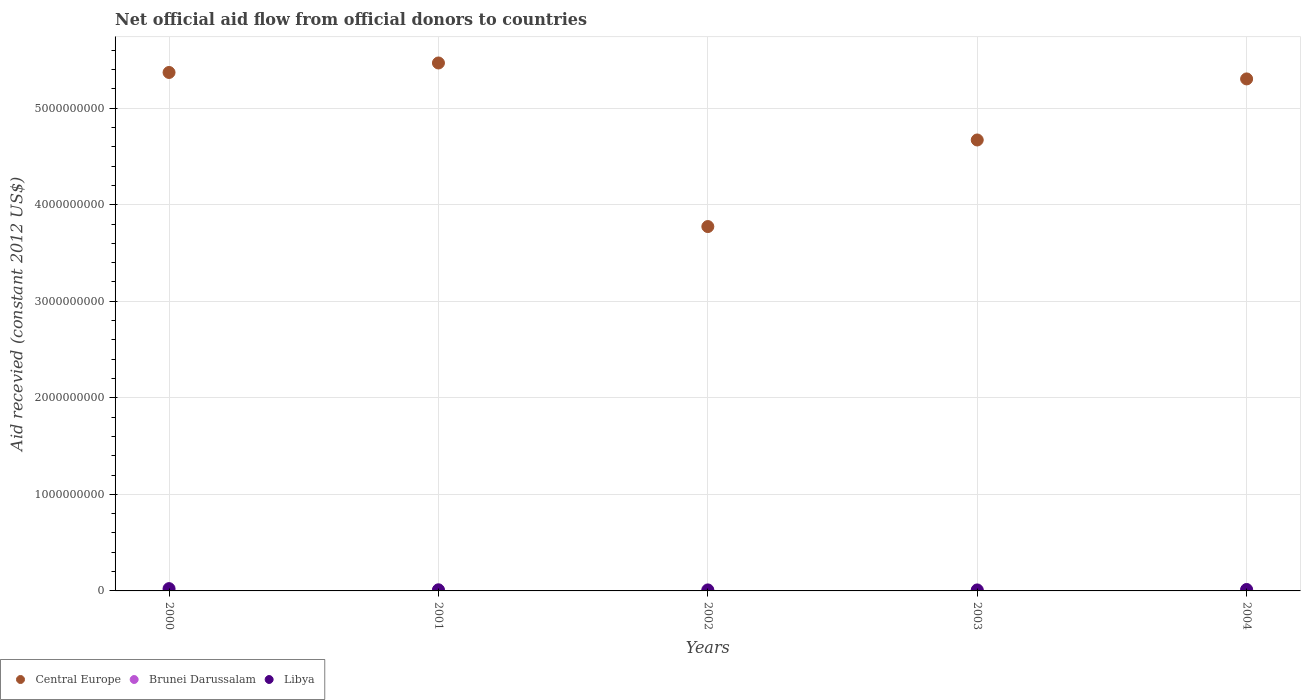Is the number of dotlines equal to the number of legend labels?
Your answer should be very brief. No. What is the total aid received in Brunei Darussalam in 2001?
Provide a succinct answer. 6.00e+05. Across all years, what is the maximum total aid received in Central Europe?
Offer a terse response. 5.47e+09. What is the total total aid received in Libya in the graph?
Your answer should be compact. 7.14e+07. What is the difference between the total aid received in Central Europe in 2003 and that in 2004?
Provide a short and direct response. -6.32e+08. What is the difference between the total aid received in Libya in 2002 and the total aid received in Brunei Darussalam in 2001?
Keep it short and to the point. 9.91e+06. What is the average total aid received in Libya per year?
Your answer should be very brief. 1.43e+07. In the year 2002, what is the difference between the total aid received in Libya and total aid received in Central Europe?
Offer a very short reply. -3.76e+09. In how many years, is the total aid received in Libya greater than 4000000000 US$?
Your answer should be very brief. 0. What is the ratio of the total aid received in Libya in 2000 to that in 2004?
Keep it short and to the point. 1.58. Is the total aid received in Central Europe in 2002 less than that in 2004?
Your answer should be very brief. Yes. What is the difference between the highest and the second highest total aid received in Libya?
Your answer should be very brief. 8.78e+06. What is the difference between the highest and the lowest total aid received in Central Europe?
Offer a terse response. 1.69e+09. In how many years, is the total aid received in Brunei Darussalam greater than the average total aid received in Brunei Darussalam taken over all years?
Offer a very short reply. 2. Is it the case that in every year, the sum of the total aid received in Libya and total aid received in Central Europe  is greater than the total aid received in Brunei Darussalam?
Your answer should be compact. Yes. Does the total aid received in Brunei Darussalam monotonically increase over the years?
Your answer should be compact. No. Is the total aid received in Central Europe strictly greater than the total aid received in Libya over the years?
Ensure brevity in your answer.  Yes. Is the total aid received in Central Europe strictly less than the total aid received in Brunei Darussalam over the years?
Provide a succinct answer. No. How many dotlines are there?
Offer a terse response. 3. Does the graph contain grids?
Your response must be concise. Yes. What is the title of the graph?
Make the answer very short. Net official aid flow from official donors to countries. What is the label or title of the X-axis?
Give a very brief answer. Years. What is the label or title of the Y-axis?
Make the answer very short. Aid recevied (constant 2012 US$). What is the Aid recevied (constant 2012 US$) in Central Europe in 2000?
Your response must be concise. 5.37e+09. What is the Aid recevied (constant 2012 US$) of Brunei Darussalam in 2000?
Make the answer very short. 1.21e+06. What is the Aid recevied (constant 2012 US$) of Libya in 2000?
Your response must be concise. 2.38e+07. What is the Aid recevied (constant 2012 US$) in Central Europe in 2001?
Keep it short and to the point. 5.47e+09. What is the Aid recevied (constant 2012 US$) of Libya in 2001?
Offer a very short reply. 1.17e+07. What is the Aid recevied (constant 2012 US$) in Central Europe in 2002?
Keep it short and to the point. 3.77e+09. What is the Aid recevied (constant 2012 US$) in Libya in 2002?
Ensure brevity in your answer.  1.05e+07. What is the Aid recevied (constant 2012 US$) in Central Europe in 2003?
Offer a very short reply. 4.67e+09. What is the Aid recevied (constant 2012 US$) in Libya in 2003?
Provide a succinct answer. 1.03e+07. What is the Aid recevied (constant 2012 US$) of Central Europe in 2004?
Your answer should be very brief. 5.30e+09. What is the Aid recevied (constant 2012 US$) of Brunei Darussalam in 2004?
Provide a succinct answer. 9.40e+05. What is the Aid recevied (constant 2012 US$) in Libya in 2004?
Offer a very short reply. 1.50e+07. Across all years, what is the maximum Aid recevied (constant 2012 US$) of Central Europe?
Provide a short and direct response. 5.47e+09. Across all years, what is the maximum Aid recevied (constant 2012 US$) of Brunei Darussalam?
Your answer should be very brief. 1.21e+06. Across all years, what is the maximum Aid recevied (constant 2012 US$) of Libya?
Your answer should be compact. 2.38e+07. Across all years, what is the minimum Aid recevied (constant 2012 US$) of Central Europe?
Provide a short and direct response. 3.77e+09. Across all years, what is the minimum Aid recevied (constant 2012 US$) in Brunei Darussalam?
Ensure brevity in your answer.  0. Across all years, what is the minimum Aid recevied (constant 2012 US$) in Libya?
Provide a short and direct response. 1.03e+07. What is the total Aid recevied (constant 2012 US$) of Central Europe in the graph?
Your answer should be very brief. 2.46e+1. What is the total Aid recevied (constant 2012 US$) of Brunei Darussalam in the graph?
Your answer should be very brief. 3.35e+06. What is the total Aid recevied (constant 2012 US$) in Libya in the graph?
Give a very brief answer. 7.14e+07. What is the difference between the Aid recevied (constant 2012 US$) in Central Europe in 2000 and that in 2001?
Your response must be concise. -9.83e+07. What is the difference between the Aid recevied (constant 2012 US$) in Libya in 2000 and that in 2001?
Keep it short and to the point. 1.21e+07. What is the difference between the Aid recevied (constant 2012 US$) of Central Europe in 2000 and that in 2002?
Your answer should be very brief. 1.60e+09. What is the difference between the Aid recevied (constant 2012 US$) in Libya in 2000 and that in 2002?
Your answer should be very brief. 1.33e+07. What is the difference between the Aid recevied (constant 2012 US$) in Central Europe in 2000 and that in 2003?
Provide a short and direct response. 6.99e+08. What is the difference between the Aid recevied (constant 2012 US$) of Brunei Darussalam in 2000 and that in 2003?
Your response must be concise. 6.10e+05. What is the difference between the Aid recevied (constant 2012 US$) of Libya in 2000 and that in 2003?
Provide a succinct answer. 1.34e+07. What is the difference between the Aid recevied (constant 2012 US$) of Central Europe in 2000 and that in 2004?
Your answer should be very brief. 6.68e+07. What is the difference between the Aid recevied (constant 2012 US$) of Brunei Darussalam in 2000 and that in 2004?
Your answer should be compact. 2.70e+05. What is the difference between the Aid recevied (constant 2012 US$) of Libya in 2000 and that in 2004?
Your answer should be very brief. 8.78e+06. What is the difference between the Aid recevied (constant 2012 US$) in Central Europe in 2001 and that in 2002?
Offer a terse response. 1.69e+09. What is the difference between the Aid recevied (constant 2012 US$) in Libya in 2001 and that in 2002?
Your response must be concise. 1.22e+06. What is the difference between the Aid recevied (constant 2012 US$) of Central Europe in 2001 and that in 2003?
Ensure brevity in your answer.  7.98e+08. What is the difference between the Aid recevied (constant 2012 US$) of Brunei Darussalam in 2001 and that in 2003?
Provide a short and direct response. 0. What is the difference between the Aid recevied (constant 2012 US$) in Libya in 2001 and that in 2003?
Make the answer very short. 1.39e+06. What is the difference between the Aid recevied (constant 2012 US$) of Central Europe in 2001 and that in 2004?
Your answer should be compact. 1.65e+08. What is the difference between the Aid recevied (constant 2012 US$) of Libya in 2001 and that in 2004?
Your answer should be compact. -3.28e+06. What is the difference between the Aid recevied (constant 2012 US$) of Central Europe in 2002 and that in 2003?
Provide a succinct answer. -8.97e+08. What is the difference between the Aid recevied (constant 2012 US$) in Libya in 2002 and that in 2003?
Keep it short and to the point. 1.70e+05. What is the difference between the Aid recevied (constant 2012 US$) of Central Europe in 2002 and that in 2004?
Provide a short and direct response. -1.53e+09. What is the difference between the Aid recevied (constant 2012 US$) in Libya in 2002 and that in 2004?
Provide a short and direct response. -4.50e+06. What is the difference between the Aid recevied (constant 2012 US$) in Central Europe in 2003 and that in 2004?
Your answer should be compact. -6.32e+08. What is the difference between the Aid recevied (constant 2012 US$) in Libya in 2003 and that in 2004?
Offer a very short reply. -4.67e+06. What is the difference between the Aid recevied (constant 2012 US$) in Central Europe in 2000 and the Aid recevied (constant 2012 US$) in Brunei Darussalam in 2001?
Your answer should be very brief. 5.37e+09. What is the difference between the Aid recevied (constant 2012 US$) of Central Europe in 2000 and the Aid recevied (constant 2012 US$) of Libya in 2001?
Your answer should be compact. 5.36e+09. What is the difference between the Aid recevied (constant 2012 US$) in Brunei Darussalam in 2000 and the Aid recevied (constant 2012 US$) in Libya in 2001?
Make the answer very short. -1.05e+07. What is the difference between the Aid recevied (constant 2012 US$) in Central Europe in 2000 and the Aid recevied (constant 2012 US$) in Libya in 2002?
Your answer should be very brief. 5.36e+09. What is the difference between the Aid recevied (constant 2012 US$) in Brunei Darussalam in 2000 and the Aid recevied (constant 2012 US$) in Libya in 2002?
Your answer should be very brief. -9.30e+06. What is the difference between the Aid recevied (constant 2012 US$) of Central Europe in 2000 and the Aid recevied (constant 2012 US$) of Brunei Darussalam in 2003?
Give a very brief answer. 5.37e+09. What is the difference between the Aid recevied (constant 2012 US$) of Central Europe in 2000 and the Aid recevied (constant 2012 US$) of Libya in 2003?
Give a very brief answer. 5.36e+09. What is the difference between the Aid recevied (constant 2012 US$) in Brunei Darussalam in 2000 and the Aid recevied (constant 2012 US$) in Libya in 2003?
Offer a terse response. -9.13e+06. What is the difference between the Aid recevied (constant 2012 US$) in Central Europe in 2000 and the Aid recevied (constant 2012 US$) in Brunei Darussalam in 2004?
Ensure brevity in your answer.  5.37e+09. What is the difference between the Aid recevied (constant 2012 US$) in Central Europe in 2000 and the Aid recevied (constant 2012 US$) in Libya in 2004?
Ensure brevity in your answer.  5.36e+09. What is the difference between the Aid recevied (constant 2012 US$) of Brunei Darussalam in 2000 and the Aid recevied (constant 2012 US$) of Libya in 2004?
Offer a very short reply. -1.38e+07. What is the difference between the Aid recevied (constant 2012 US$) of Central Europe in 2001 and the Aid recevied (constant 2012 US$) of Libya in 2002?
Provide a succinct answer. 5.46e+09. What is the difference between the Aid recevied (constant 2012 US$) of Brunei Darussalam in 2001 and the Aid recevied (constant 2012 US$) of Libya in 2002?
Keep it short and to the point. -9.91e+06. What is the difference between the Aid recevied (constant 2012 US$) in Central Europe in 2001 and the Aid recevied (constant 2012 US$) in Brunei Darussalam in 2003?
Your answer should be very brief. 5.47e+09. What is the difference between the Aid recevied (constant 2012 US$) in Central Europe in 2001 and the Aid recevied (constant 2012 US$) in Libya in 2003?
Give a very brief answer. 5.46e+09. What is the difference between the Aid recevied (constant 2012 US$) in Brunei Darussalam in 2001 and the Aid recevied (constant 2012 US$) in Libya in 2003?
Make the answer very short. -9.74e+06. What is the difference between the Aid recevied (constant 2012 US$) of Central Europe in 2001 and the Aid recevied (constant 2012 US$) of Brunei Darussalam in 2004?
Provide a succinct answer. 5.47e+09. What is the difference between the Aid recevied (constant 2012 US$) in Central Europe in 2001 and the Aid recevied (constant 2012 US$) in Libya in 2004?
Your answer should be very brief. 5.45e+09. What is the difference between the Aid recevied (constant 2012 US$) of Brunei Darussalam in 2001 and the Aid recevied (constant 2012 US$) of Libya in 2004?
Your response must be concise. -1.44e+07. What is the difference between the Aid recevied (constant 2012 US$) of Central Europe in 2002 and the Aid recevied (constant 2012 US$) of Brunei Darussalam in 2003?
Your answer should be compact. 3.77e+09. What is the difference between the Aid recevied (constant 2012 US$) of Central Europe in 2002 and the Aid recevied (constant 2012 US$) of Libya in 2003?
Offer a terse response. 3.76e+09. What is the difference between the Aid recevied (constant 2012 US$) in Central Europe in 2002 and the Aid recevied (constant 2012 US$) in Brunei Darussalam in 2004?
Make the answer very short. 3.77e+09. What is the difference between the Aid recevied (constant 2012 US$) of Central Europe in 2002 and the Aid recevied (constant 2012 US$) of Libya in 2004?
Your answer should be very brief. 3.76e+09. What is the difference between the Aid recevied (constant 2012 US$) in Central Europe in 2003 and the Aid recevied (constant 2012 US$) in Brunei Darussalam in 2004?
Offer a terse response. 4.67e+09. What is the difference between the Aid recevied (constant 2012 US$) in Central Europe in 2003 and the Aid recevied (constant 2012 US$) in Libya in 2004?
Provide a short and direct response. 4.66e+09. What is the difference between the Aid recevied (constant 2012 US$) in Brunei Darussalam in 2003 and the Aid recevied (constant 2012 US$) in Libya in 2004?
Your answer should be compact. -1.44e+07. What is the average Aid recevied (constant 2012 US$) in Central Europe per year?
Your answer should be compact. 4.92e+09. What is the average Aid recevied (constant 2012 US$) of Brunei Darussalam per year?
Offer a very short reply. 6.70e+05. What is the average Aid recevied (constant 2012 US$) in Libya per year?
Give a very brief answer. 1.43e+07. In the year 2000, what is the difference between the Aid recevied (constant 2012 US$) in Central Europe and Aid recevied (constant 2012 US$) in Brunei Darussalam?
Provide a short and direct response. 5.37e+09. In the year 2000, what is the difference between the Aid recevied (constant 2012 US$) in Central Europe and Aid recevied (constant 2012 US$) in Libya?
Your answer should be compact. 5.35e+09. In the year 2000, what is the difference between the Aid recevied (constant 2012 US$) in Brunei Darussalam and Aid recevied (constant 2012 US$) in Libya?
Offer a terse response. -2.26e+07. In the year 2001, what is the difference between the Aid recevied (constant 2012 US$) of Central Europe and Aid recevied (constant 2012 US$) of Brunei Darussalam?
Offer a terse response. 5.47e+09. In the year 2001, what is the difference between the Aid recevied (constant 2012 US$) in Central Europe and Aid recevied (constant 2012 US$) in Libya?
Keep it short and to the point. 5.46e+09. In the year 2001, what is the difference between the Aid recevied (constant 2012 US$) of Brunei Darussalam and Aid recevied (constant 2012 US$) of Libya?
Your response must be concise. -1.11e+07. In the year 2002, what is the difference between the Aid recevied (constant 2012 US$) in Central Europe and Aid recevied (constant 2012 US$) in Libya?
Offer a very short reply. 3.76e+09. In the year 2003, what is the difference between the Aid recevied (constant 2012 US$) in Central Europe and Aid recevied (constant 2012 US$) in Brunei Darussalam?
Offer a very short reply. 4.67e+09. In the year 2003, what is the difference between the Aid recevied (constant 2012 US$) in Central Europe and Aid recevied (constant 2012 US$) in Libya?
Provide a short and direct response. 4.66e+09. In the year 2003, what is the difference between the Aid recevied (constant 2012 US$) of Brunei Darussalam and Aid recevied (constant 2012 US$) of Libya?
Give a very brief answer. -9.74e+06. In the year 2004, what is the difference between the Aid recevied (constant 2012 US$) of Central Europe and Aid recevied (constant 2012 US$) of Brunei Darussalam?
Your response must be concise. 5.30e+09. In the year 2004, what is the difference between the Aid recevied (constant 2012 US$) in Central Europe and Aid recevied (constant 2012 US$) in Libya?
Ensure brevity in your answer.  5.29e+09. In the year 2004, what is the difference between the Aid recevied (constant 2012 US$) in Brunei Darussalam and Aid recevied (constant 2012 US$) in Libya?
Ensure brevity in your answer.  -1.41e+07. What is the ratio of the Aid recevied (constant 2012 US$) of Central Europe in 2000 to that in 2001?
Offer a very short reply. 0.98. What is the ratio of the Aid recevied (constant 2012 US$) of Brunei Darussalam in 2000 to that in 2001?
Your answer should be compact. 2.02. What is the ratio of the Aid recevied (constant 2012 US$) of Libya in 2000 to that in 2001?
Offer a very short reply. 2.03. What is the ratio of the Aid recevied (constant 2012 US$) of Central Europe in 2000 to that in 2002?
Offer a very short reply. 1.42. What is the ratio of the Aid recevied (constant 2012 US$) of Libya in 2000 to that in 2002?
Offer a terse response. 2.26. What is the ratio of the Aid recevied (constant 2012 US$) in Central Europe in 2000 to that in 2003?
Your answer should be compact. 1.15. What is the ratio of the Aid recevied (constant 2012 US$) in Brunei Darussalam in 2000 to that in 2003?
Provide a succinct answer. 2.02. What is the ratio of the Aid recevied (constant 2012 US$) in Libya in 2000 to that in 2003?
Give a very brief answer. 2.3. What is the ratio of the Aid recevied (constant 2012 US$) in Central Europe in 2000 to that in 2004?
Offer a very short reply. 1.01. What is the ratio of the Aid recevied (constant 2012 US$) of Brunei Darussalam in 2000 to that in 2004?
Your answer should be very brief. 1.29. What is the ratio of the Aid recevied (constant 2012 US$) of Libya in 2000 to that in 2004?
Keep it short and to the point. 1.58. What is the ratio of the Aid recevied (constant 2012 US$) of Central Europe in 2001 to that in 2002?
Provide a succinct answer. 1.45. What is the ratio of the Aid recevied (constant 2012 US$) of Libya in 2001 to that in 2002?
Your answer should be very brief. 1.12. What is the ratio of the Aid recevied (constant 2012 US$) in Central Europe in 2001 to that in 2003?
Ensure brevity in your answer.  1.17. What is the ratio of the Aid recevied (constant 2012 US$) of Libya in 2001 to that in 2003?
Make the answer very short. 1.13. What is the ratio of the Aid recevied (constant 2012 US$) in Central Europe in 2001 to that in 2004?
Give a very brief answer. 1.03. What is the ratio of the Aid recevied (constant 2012 US$) of Brunei Darussalam in 2001 to that in 2004?
Ensure brevity in your answer.  0.64. What is the ratio of the Aid recevied (constant 2012 US$) of Libya in 2001 to that in 2004?
Your answer should be very brief. 0.78. What is the ratio of the Aid recevied (constant 2012 US$) of Central Europe in 2002 to that in 2003?
Offer a terse response. 0.81. What is the ratio of the Aid recevied (constant 2012 US$) in Libya in 2002 to that in 2003?
Your answer should be compact. 1.02. What is the ratio of the Aid recevied (constant 2012 US$) in Central Europe in 2002 to that in 2004?
Offer a very short reply. 0.71. What is the ratio of the Aid recevied (constant 2012 US$) of Libya in 2002 to that in 2004?
Make the answer very short. 0.7. What is the ratio of the Aid recevied (constant 2012 US$) of Central Europe in 2003 to that in 2004?
Your response must be concise. 0.88. What is the ratio of the Aid recevied (constant 2012 US$) of Brunei Darussalam in 2003 to that in 2004?
Offer a very short reply. 0.64. What is the ratio of the Aid recevied (constant 2012 US$) in Libya in 2003 to that in 2004?
Your response must be concise. 0.69. What is the difference between the highest and the second highest Aid recevied (constant 2012 US$) of Central Europe?
Offer a terse response. 9.83e+07. What is the difference between the highest and the second highest Aid recevied (constant 2012 US$) of Libya?
Provide a succinct answer. 8.78e+06. What is the difference between the highest and the lowest Aid recevied (constant 2012 US$) of Central Europe?
Provide a short and direct response. 1.69e+09. What is the difference between the highest and the lowest Aid recevied (constant 2012 US$) of Brunei Darussalam?
Provide a succinct answer. 1.21e+06. What is the difference between the highest and the lowest Aid recevied (constant 2012 US$) of Libya?
Your answer should be very brief. 1.34e+07. 